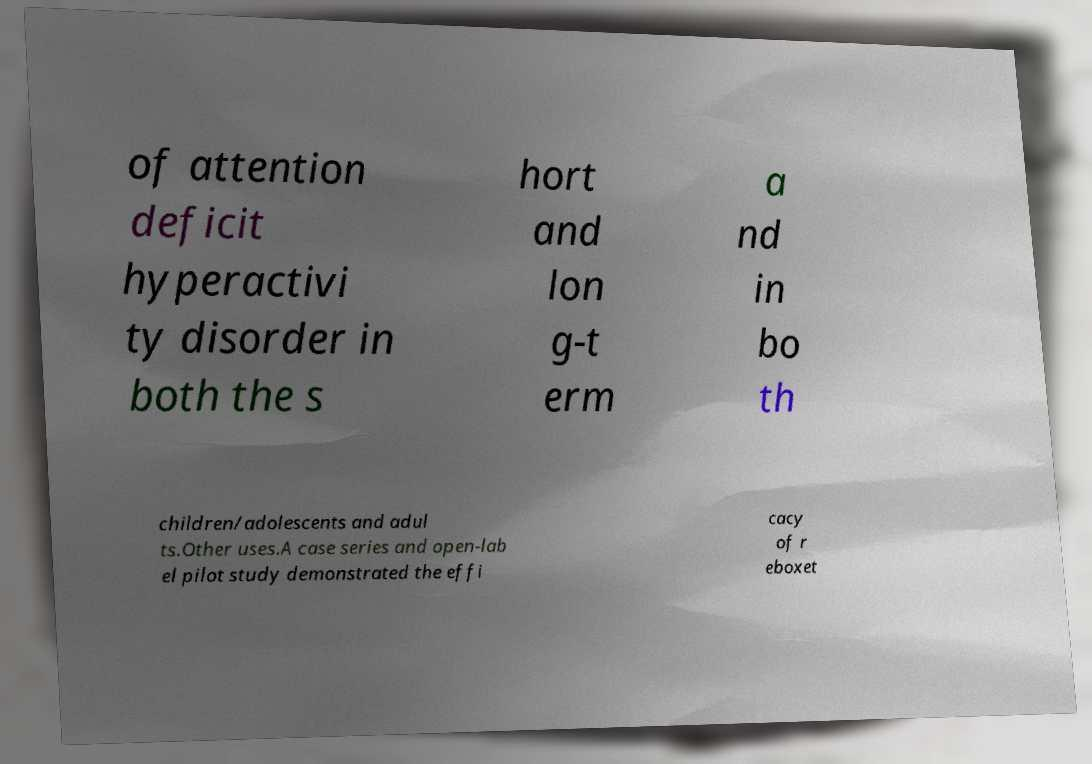What messages or text are displayed in this image? I need them in a readable, typed format. of attention deficit hyperactivi ty disorder in both the s hort and lon g-t erm a nd in bo th children/adolescents and adul ts.Other uses.A case series and open-lab el pilot study demonstrated the effi cacy of r eboxet 